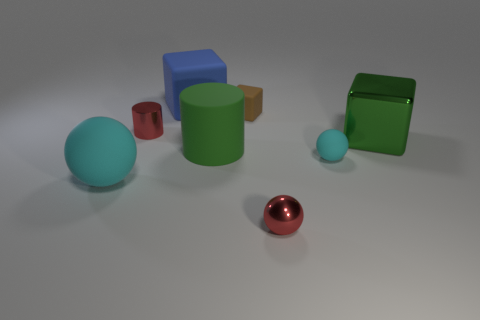What can you infer about the purpose of this composition? The composition appears to be a deliberate arrangement of geometric shapes and contrasting colors, which could be an artistic study in form, lighting, and color dynamics, or a digital rendering to demonstrate 3D modeling and material textures. It may also serve as a visual reference for spatial relationships and perspective. 